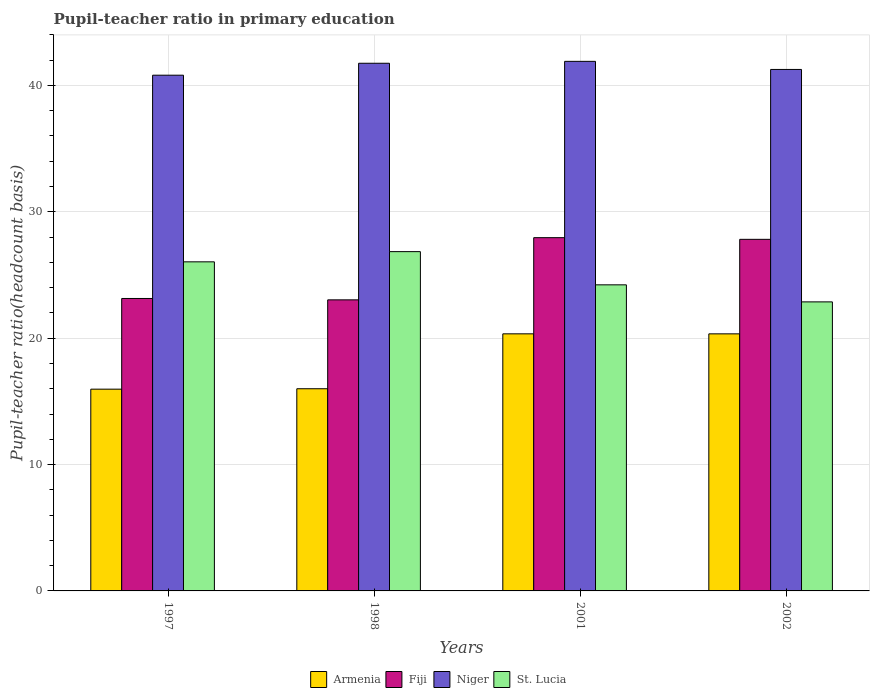How many groups of bars are there?
Ensure brevity in your answer.  4. Are the number of bars on each tick of the X-axis equal?
Make the answer very short. Yes. How many bars are there on the 3rd tick from the right?
Your response must be concise. 4. What is the label of the 1st group of bars from the left?
Your response must be concise. 1997. In how many cases, is the number of bars for a given year not equal to the number of legend labels?
Provide a succinct answer. 0. What is the pupil-teacher ratio in primary education in Niger in 2001?
Make the answer very short. 41.91. Across all years, what is the maximum pupil-teacher ratio in primary education in Fiji?
Keep it short and to the point. 27.95. Across all years, what is the minimum pupil-teacher ratio in primary education in Fiji?
Your answer should be very brief. 23.03. In which year was the pupil-teacher ratio in primary education in Armenia maximum?
Your answer should be compact. 2001. In which year was the pupil-teacher ratio in primary education in Armenia minimum?
Offer a terse response. 1997. What is the total pupil-teacher ratio in primary education in St. Lucia in the graph?
Keep it short and to the point. 99.99. What is the difference between the pupil-teacher ratio in primary education in Niger in 1997 and that in 2002?
Keep it short and to the point. -0.45. What is the difference between the pupil-teacher ratio in primary education in Niger in 1998 and the pupil-teacher ratio in primary education in St. Lucia in 2001?
Your response must be concise. 17.53. What is the average pupil-teacher ratio in primary education in Fiji per year?
Provide a short and direct response. 25.49. In the year 1997, what is the difference between the pupil-teacher ratio in primary education in St. Lucia and pupil-teacher ratio in primary education in Armenia?
Offer a terse response. 10.08. In how many years, is the pupil-teacher ratio in primary education in Niger greater than 12?
Make the answer very short. 4. What is the ratio of the pupil-teacher ratio in primary education in St. Lucia in 1997 to that in 2001?
Your answer should be very brief. 1.08. Is the pupil-teacher ratio in primary education in Armenia in 1998 less than that in 2002?
Your response must be concise. Yes. Is the difference between the pupil-teacher ratio in primary education in St. Lucia in 1997 and 2001 greater than the difference between the pupil-teacher ratio in primary education in Armenia in 1997 and 2001?
Your answer should be very brief. Yes. What is the difference between the highest and the second highest pupil-teacher ratio in primary education in St. Lucia?
Make the answer very short. 0.81. What is the difference between the highest and the lowest pupil-teacher ratio in primary education in Niger?
Provide a short and direct response. 1.1. Is it the case that in every year, the sum of the pupil-teacher ratio in primary education in Niger and pupil-teacher ratio in primary education in Armenia is greater than the sum of pupil-teacher ratio in primary education in Fiji and pupil-teacher ratio in primary education in St. Lucia?
Ensure brevity in your answer.  Yes. What does the 2nd bar from the left in 2001 represents?
Give a very brief answer. Fiji. What does the 3rd bar from the right in 2002 represents?
Provide a succinct answer. Fiji. How many years are there in the graph?
Give a very brief answer. 4. What is the difference between two consecutive major ticks on the Y-axis?
Make the answer very short. 10. Does the graph contain grids?
Give a very brief answer. Yes. Where does the legend appear in the graph?
Provide a succinct answer. Bottom center. How many legend labels are there?
Your response must be concise. 4. How are the legend labels stacked?
Your response must be concise. Horizontal. What is the title of the graph?
Provide a succinct answer. Pupil-teacher ratio in primary education. What is the label or title of the Y-axis?
Offer a terse response. Pupil-teacher ratio(headcount basis). What is the Pupil-teacher ratio(headcount basis) of Armenia in 1997?
Provide a short and direct response. 15.97. What is the Pupil-teacher ratio(headcount basis) in Fiji in 1997?
Keep it short and to the point. 23.14. What is the Pupil-teacher ratio(headcount basis) of Niger in 1997?
Offer a very short reply. 40.81. What is the Pupil-teacher ratio(headcount basis) of St. Lucia in 1997?
Keep it short and to the point. 26.04. What is the Pupil-teacher ratio(headcount basis) in Armenia in 1998?
Your answer should be very brief. 16. What is the Pupil-teacher ratio(headcount basis) of Fiji in 1998?
Your answer should be compact. 23.03. What is the Pupil-teacher ratio(headcount basis) in Niger in 1998?
Your response must be concise. 41.76. What is the Pupil-teacher ratio(headcount basis) of St. Lucia in 1998?
Give a very brief answer. 26.85. What is the Pupil-teacher ratio(headcount basis) in Armenia in 2001?
Your answer should be very brief. 20.34. What is the Pupil-teacher ratio(headcount basis) in Fiji in 2001?
Provide a short and direct response. 27.95. What is the Pupil-teacher ratio(headcount basis) of Niger in 2001?
Provide a succinct answer. 41.91. What is the Pupil-teacher ratio(headcount basis) of St. Lucia in 2001?
Provide a succinct answer. 24.22. What is the Pupil-teacher ratio(headcount basis) in Armenia in 2002?
Your response must be concise. 20.34. What is the Pupil-teacher ratio(headcount basis) of Fiji in 2002?
Make the answer very short. 27.82. What is the Pupil-teacher ratio(headcount basis) in Niger in 2002?
Give a very brief answer. 41.27. What is the Pupil-teacher ratio(headcount basis) in St. Lucia in 2002?
Provide a succinct answer. 22.87. Across all years, what is the maximum Pupil-teacher ratio(headcount basis) in Armenia?
Give a very brief answer. 20.34. Across all years, what is the maximum Pupil-teacher ratio(headcount basis) in Fiji?
Your response must be concise. 27.95. Across all years, what is the maximum Pupil-teacher ratio(headcount basis) of Niger?
Provide a succinct answer. 41.91. Across all years, what is the maximum Pupil-teacher ratio(headcount basis) of St. Lucia?
Keep it short and to the point. 26.85. Across all years, what is the minimum Pupil-teacher ratio(headcount basis) of Armenia?
Your answer should be compact. 15.97. Across all years, what is the minimum Pupil-teacher ratio(headcount basis) in Fiji?
Keep it short and to the point. 23.03. Across all years, what is the minimum Pupil-teacher ratio(headcount basis) in Niger?
Your answer should be compact. 40.81. Across all years, what is the minimum Pupil-teacher ratio(headcount basis) of St. Lucia?
Provide a succinct answer. 22.87. What is the total Pupil-teacher ratio(headcount basis) of Armenia in the graph?
Keep it short and to the point. 72.65. What is the total Pupil-teacher ratio(headcount basis) of Fiji in the graph?
Your response must be concise. 101.95. What is the total Pupil-teacher ratio(headcount basis) in Niger in the graph?
Provide a succinct answer. 165.74. What is the total Pupil-teacher ratio(headcount basis) of St. Lucia in the graph?
Your answer should be compact. 99.99. What is the difference between the Pupil-teacher ratio(headcount basis) in Armenia in 1997 and that in 1998?
Provide a succinct answer. -0.03. What is the difference between the Pupil-teacher ratio(headcount basis) of Fiji in 1997 and that in 1998?
Offer a terse response. 0.11. What is the difference between the Pupil-teacher ratio(headcount basis) of Niger in 1997 and that in 1998?
Offer a terse response. -0.94. What is the difference between the Pupil-teacher ratio(headcount basis) in St. Lucia in 1997 and that in 1998?
Your response must be concise. -0.81. What is the difference between the Pupil-teacher ratio(headcount basis) in Armenia in 1997 and that in 2001?
Keep it short and to the point. -4.38. What is the difference between the Pupil-teacher ratio(headcount basis) of Fiji in 1997 and that in 2001?
Provide a short and direct response. -4.81. What is the difference between the Pupil-teacher ratio(headcount basis) of Niger in 1997 and that in 2001?
Make the answer very short. -1.1. What is the difference between the Pupil-teacher ratio(headcount basis) of St. Lucia in 1997 and that in 2001?
Make the answer very short. 1.82. What is the difference between the Pupil-teacher ratio(headcount basis) in Armenia in 1997 and that in 2002?
Your answer should be compact. -4.38. What is the difference between the Pupil-teacher ratio(headcount basis) of Fiji in 1997 and that in 2002?
Give a very brief answer. -4.68. What is the difference between the Pupil-teacher ratio(headcount basis) in Niger in 1997 and that in 2002?
Your response must be concise. -0.46. What is the difference between the Pupil-teacher ratio(headcount basis) in St. Lucia in 1997 and that in 2002?
Offer a very short reply. 3.17. What is the difference between the Pupil-teacher ratio(headcount basis) of Armenia in 1998 and that in 2001?
Your answer should be very brief. -4.34. What is the difference between the Pupil-teacher ratio(headcount basis) of Fiji in 1998 and that in 2001?
Provide a short and direct response. -4.92. What is the difference between the Pupil-teacher ratio(headcount basis) of Niger in 1998 and that in 2001?
Offer a terse response. -0.15. What is the difference between the Pupil-teacher ratio(headcount basis) of St. Lucia in 1998 and that in 2001?
Your response must be concise. 2.63. What is the difference between the Pupil-teacher ratio(headcount basis) of Armenia in 1998 and that in 2002?
Your answer should be very brief. -4.34. What is the difference between the Pupil-teacher ratio(headcount basis) in Fiji in 1998 and that in 2002?
Give a very brief answer. -4.79. What is the difference between the Pupil-teacher ratio(headcount basis) in Niger in 1998 and that in 2002?
Make the answer very short. 0.49. What is the difference between the Pupil-teacher ratio(headcount basis) in St. Lucia in 1998 and that in 2002?
Your answer should be very brief. 3.98. What is the difference between the Pupil-teacher ratio(headcount basis) of Armenia in 2001 and that in 2002?
Offer a very short reply. 0. What is the difference between the Pupil-teacher ratio(headcount basis) of Fiji in 2001 and that in 2002?
Your response must be concise. 0.13. What is the difference between the Pupil-teacher ratio(headcount basis) in Niger in 2001 and that in 2002?
Your response must be concise. 0.64. What is the difference between the Pupil-teacher ratio(headcount basis) in St. Lucia in 2001 and that in 2002?
Your answer should be compact. 1.35. What is the difference between the Pupil-teacher ratio(headcount basis) in Armenia in 1997 and the Pupil-teacher ratio(headcount basis) in Fiji in 1998?
Make the answer very short. -7.07. What is the difference between the Pupil-teacher ratio(headcount basis) of Armenia in 1997 and the Pupil-teacher ratio(headcount basis) of Niger in 1998?
Your response must be concise. -25.79. What is the difference between the Pupil-teacher ratio(headcount basis) in Armenia in 1997 and the Pupil-teacher ratio(headcount basis) in St. Lucia in 1998?
Provide a short and direct response. -10.88. What is the difference between the Pupil-teacher ratio(headcount basis) of Fiji in 1997 and the Pupil-teacher ratio(headcount basis) of Niger in 1998?
Provide a short and direct response. -18.61. What is the difference between the Pupil-teacher ratio(headcount basis) in Fiji in 1997 and the Pupil-teacher ratio(headcount basis) in St. Lucia in 1998?
Provide a succinct answer. -3.71. What is the difference between the Pupil-teacher ratio(headcount basis) of Niger in 1997 and the Pupil-teacher ratio(headcount basis) of St. Lucia in 1998?
Your response must be concise. 13.96. What is the difference between the Pupil-teacher ratio(headcount basis) in Armenia in 1997 and the Pupil-teacher ratio(headcount basis) in Fiji in 2001?
Give a very brief answer. -11.99. What is the difference between the Pupil-teacher ratio(headcount basis) in Armenia in 1997 and the Pupil-teacher ratio(headcount basis) in Niger in 2001?
Your answer should be very brief. -25.94. What is the difference between the Pupil-teacher ratio(headcount basis) of Armenia in 1997 and the Pupil-teacher ratio(headcount basis) of St. Lucia in 2001?
Give a very brief answer. -8.26. What is the difference between the Pupil-teacher ratio(headcount basis) in Fiji in 1997 and the Pupil-teacher ratio(headcount basis) in Niger in 2001?
Your answer should be very brief. -18.76. What is the difference between the Pupil-teacher ratio(headcount basis) of Fiji in 1997 and the Pupil-teacher ratio(headcount basis) of St. Lucia in 2001?
Make the answer very short. -1.08. What is the difference between the Pupil-teacher ratio(headcount basis) of Niger in 1997 and the Pupil-teacher ratio(headcount basis) of St. Lucia in 2001?
Offer a very short reply. 16.59. What is the difference between the Pupil-teacher ratio(headcount basis) in Armenia in 1997 and the Pupil-teacher ratio(headcount basis) in Fiji in 2002?
Make the answer very short. -11.86. What is the difference between the Pupil-teacher ratio(headcount basis) in Armenia in 1997 and the Pupil-teacher ratio(headcount basis) in Niger in 2002?
Give a very brief answer. -25.3. What is the difference between the Pupil-teacher ratio(headcount basis) of Armenia in 1997 and the Pupil-teacher ratio(headcount basis) of St. Lucia in 2002?
Give a very brief answer. -6.91. What is the difference between the Pupil-teacher ratio(headcount basis) in Fiji in 1997 and the Pupil-teacher ratio(headcount basis) in Niger in 2002?
Offer a terse response. -18.12. What is the difference between the Pupil-teacher ratio(headcount basis) of Fiji in 1997 and the Pupil-teacher ratio(headcount basis) of St. Lucia in 2002?
Provide a succinct answer. 0.27. What is the difference between the Pupil-teacher ratio(headcount basis) in Niger in 1997 and the Pupil-teacher ratio(headcount basis) in St. Lucia in 2002?
Make the answer very short. 17.94. What is the difference between the Pupil-teacher ratio(headcount basis) of Armenia in 1998 and the Pupil-teacher ratio(headcount basis) of Fiji in 2001?
Offer a very short reply. -11.95. What is the difference between the Pupil-teacher ratio(headcount basis) in Armenia in 1998 and the Pupil-teacher ratio(headcount basis) in Niger in 2001?
Provide a succinct answer. -25.91. What is the difference between the Pupil-teacher ratio(headcount basis) in Armenia in 1998 and the Pupil-teacher ratio(headcount basis) in St. Lucia in 2001?
Your response must be concise. -8.22. What is the difference between the Pupil-teacher ratio(headcount basis) of Fiji in 1998 and the Pupil-teacher ratio(headcount basis) of Niger in 2001?
Your answer should be very brief. -18.87. What is the difference between the Pupil-teacher ratio(headcount basis) of Fiji in 1998 and the Pupil-teacher ratio(headcount basis) of St. Lucia in 2001?
Provide a short and direct response. -1.19. What is the difference between the Pupil-teacher ratio(headcount basis) of Niger in 1998 and the Pupil-teacher ratio(headcount basis) of St. Lucia in 2001?
Your answer should be compact. 17.53. What is the difference between the Pupil-teacher ratio(headcount basis) of Armenia in 1998 and the Pupil-teacher ratio(headcount basis) of Fiji in 2002?
Provide a succinct answer. -11.82. What is the difference between the Pupil-teacher ratio(headcount basis) of Armenia in 1998 and the Pupil-teacher ratio(headcount basis) of Niger in 2002?
Provide a short and direct response. -25.27. What is the difference between the Pupil-teacher ratio(headcount basis) of Armenia in 1998 and the Pupil-teacher ratio(headcount basis) of St. Lucia in 2002?
Provide a succinct answer. -6.87. What is the difference between the Pupil-teacher ratio(headcount basis) in Fiji in 1998 and the Pupil-teacher ratio(headcount basis) in Niger in 2002?
Your answer should be very brief. -18.23. What is the difference between the Pupil-teacher ratio(headcount basis) in Fiji in 1998 and the Pupil-teacher ratio(headcount basis) in St. Lucia in 2002?
Your response must be concise. 0.16. What is the difference between the Pupil-teacher ratio(headcount basis) of Niger in 1998 and the Pupil-teacher ratio(headcount basis) of St. Lucia in 2002?
Ensure brevity in your answer.  18.88. What is the difference between the Pupil-teacher ratio(headcount basis) of Armenia in 2001 and the Pupil-teacher ratio(headcount basis) of Fiji in 2002?
Your answer should be compact. -7.48. What is the difference between the Pupil-teacher ratio(headcount basis) in Armenia in 2001 and the Pupil-teacher ratio(headcount basis) in Niger in 2002?
Keep it short and to the point. -20.92. What is the difference between the Pupil-teacher ratio(headcount basis) in Armenia in 2001 and the Pupil-teacher ratio(headcount basis) in St. Lucia in 2002?
Provide a short and direct response. -2.53. What is the difference between the Pupil-teacher ratio(headcount basis) in Fiji in 2001 and the Pupil-teacher ratio(headcount basis) in Niger in 2002?
Your answer should be very brief. -13.31. What is the difference between the Pupil-teacher ratio(headcount basis) of Fiji in 2001 and the Pupil-teacher ratio(headcount basis) of St. Lucia in 2002?
Keep it short and to the point. 5.08. What is the difference between the Pupil-teacher ratio(headcount basis) in Niger in 2001 and the Pupil-teacher ratio(headcount basis) in St. Lucia in 2002?
Offer a terse response. 19.03. What is the average Pupil-teacher ratio(headcount basis) in Armenia per year?
Provide a short and direct response. 18.16. What is the average Pupil-teacher ratio(headcount basis) in Fiji per year?
Your answer should be very brief. 25.49. What is the average Pupil-teacher ratio(headcount basis) of Niger per year?
Make the answer very short. 41.43. What is the average Pupil-teacher ratio(headcount basis) of St. Lucia per year?
Your answer should be compact. 25. In the year 1997, what is the difference between the Pupil-teacher ratio(headcount basis) in Armenia and Pupil-teacher ratio(headcount basis) in Fiji?
Offer a very short reply. -7.18. In the year 1997, what is the difference between the Pupil-teacher ratio(headcount basis) of Armenia and Pupil-teacher ratio(headcount basis) of Niger?
Provide a short and direct response. -24.84. In the year 1997, what is the difference between the Pupil-teacher ratio(headcount basis) in Armenia and Pupil-teacher ratio(headcount basis) in St. Lucia?
Your answer should be compact. -10.08. In the year 1997, what is the difference between the Pupil-teacher ratio(headcount basis) of Fiji and Pupil-teacher ratio(headcount basis) of Niger?
Make the answer very short. -17.67. In the year 1997, what is the difference between the Pupil-teacher ratio(headcount basis) of Fiji and Pupil-teacher ratio(headcount basis) of St. Lucia?
Your answer should be compact. -2.9. In the year 1997, what is the difference between the Pupil-teacher ratio(headcount basis) of Niger and Pupil-teacher ratio(headcount basis) of St. Lucia?
Keep it short and to the point. 14.77. In the year 1998, what is the difference between the Pupil-teacher ratio(headcount basis) in Armenia and Pupil-teacher ratio(headcount basis) in Fiji?
Your response must be concise. -7.03. In the year 1998, what is the difference between the Pupil-teacher ratio(headcount basis) in Armenia and Pupil-teacher ratio(headcount basis) in Niger?
Your response must be concise. -25.76. In the year 1998, what is the difference between the Pupil-teacher ratio(headcount basis) of Armenia and Pupil-teacher ratio(headcount basis) of St. Lucia?
Provide a short and direct response. -10.85. In the year 1998, what is the difference between the Pupil-teacher ratio(headcount basis) of Fiji and Pupil-teacher ratio(headcount basis) of Niger?
Ensure brevity in your answer.  -18.72. In the year 1998, what is the difference between the Pupil-teacher ratio(headcount basis) in Fiji and Pupil-teacher ratio(headcount basis) in St. Lucia?
Keep it short and to the point. -3.82. In the year 1998, what is the difference between the Pupil-teacher ratio(headcount basis) of Niger and Pupil-teacher ratio(headcount basis) of St. Lucia?
Offer a very short reply. 14.91. In the year 2001, what is the difference between the Pupil-teacher ratio(headcount basis) of Armenia and Pupil-teacher ratio(headcount basis) of Fiji?
Provide a short and direct response. -7.61. In the year 2001, what is the difference between the Pupil-teacher ratio(headcount basis) of Armenia and Pupil-teacher ratio(headcount basis) of Niger?
Provide a succinct answer. -21.56. In the year 2001, what is the difference between the Pupil-teacher ratio(headcount basis) in Armenia and Pupil-teacher ratio(headcount basis) in St. Lucia?
Make the answer very short. -3.88. In the year 2001, what is the difference between the Pupil-teacher ratio(headcount basis) in Fiji and Pupil-teacher ratio(headcount basis) in Niger?
Your response must be concise. -13.95. In the year 2001, what is the difference between the Pupil-teacher ratio(headcount basis) of Fiji and Pupil-teacher ratio(headcount basis) of St. Lucia?
Keep it short and to the point. 3.73. In the year 2001, what is the difference between the Pupil-teacher ratio(headcount basis) in Niger and Pupil-teacher ratio(headcount basis) in St. Lucia?
Offer a very short reply. 17.68. In the year 2002, what is the difference between the Pupil-teacher ratio(headcount basis) of Armenia and Pupil-teacher ratio(headcount basis) of Fiji?
Give a very brief answer. -7.48. In the year 2002, what is the difference between the Pupil-teacher ratio(headcount basis) of Armenia and Pupil-teacher ratio(headcount basis) of Niger?
Make the answer very short. -20.92. In the year 2002, what is the difference between the Pupil-teacher ratio(headcount basis) of Armenia and Pupil-teacher ratio(headcount basis) of St. Lucia?
Make the answer very short. -2.53. In the year 2002, what is the difference between the Pupil-teacher ratio(headcount basis) of Fiji and Pupil-teacher ratio(headcount basis) of Niger?
Keep it short and to the point. -13.44. In the year 2002, what is the difference between the Pupil-teacher ratio(headcount basis) of Fiji and Pupil-teacher ratio(headcount basis) of St. Lucia?
Your response must be concise. 4.95. In the year 2002, what is the difference between the Pupil-teacher ratio(headcount basis) in Niger and Pupil-teacher ratio(headcount basis) in St. Lucia?
Offer a terse response. 18.39. What is the ratio of the Pupil-teacher ratio(headcount basis) in Fiji in 1997 to that in 1998?
Provide a succinct answer. 1. What is the ratio of the Pupil-teacher ratio(headcount basis) of Niger in 1997 to that in 1998?
Offer a very short reply. 0.98. What is the ratio of the Pupil-teacher ratio(headcount basis) of St. Lucia in 1997 to that in 1998?
Offer a terse response. 0.97. What is the ratio of the Pupil-teacher ratio(headcount basis) in Armenia in 1997 to that in 2001?
Offer a terse response. 0.78. What is the ratio of the Pupil-teacher ratio(headcount basis) of Fiji in 1997 to that in 2001?
Offer a terse response. 0.83. What is the ratio of the Pupil-teacher ratio(headcount basis) in Niger in 1997 to that in 2001?
Make the answer very short. 0.97. What is the ratio of the Pupil-teacher ratio(headcount basis) in St. Lucia in 1997 to that in 2001?
Your response must be concise. 1.08. What is the ratio of the Pupil-teacher ratio(headcount basis) in Armenia in 1997 to that in 2002?
Provide a succinct answer. 0.78. What is the ratio of the Pupil-teacher ratio(headcount basis) in Fiji in 1997 to that in 2002?
Ensure brevity in your answer.  0.83. What is the ratio of the Pupil-teacher ratio(headcount basis) in St. Lucia in 1997 to that in 2002?
Provide a short and direct response. 1.14. What is the ratio of the Pupil-teacher ratio(headcount basis) of Armenia in 1998 to that in 2001?
Keep it short and to the point. 0.79. What is the ratio of the Pupil-teacher ratio(headcount basis) in Fiji in 1998 to that in 2001?
Keep it short and to the point. 0.82. What is the ratio of the Pupil-teacher ratio(headcount basis) in St. Lucia in 1998 to that in 2001?
Give a very brief answer. 1.11. What is the ratio of the Pupil-teacher ratio(headcount basis) of Armenia in 1998 to that in 2002?
Your answer should be very brief. 0.79. What is the ratio of the Pupil-teacher ratio(headcount basis) in Fiji in 1998 to that in 2002?
Give a very brief answer. 0.83. What is the ratio of the Pupil-teacher ratio(headcount basis) in Niger in 1998 to that in 2002?
Offer a very short reply. 1.01. What is the ratio of the Pupil-teacher ratio(headcount basis) in St. Lucia in 1998 to that in 2002?
Your answer should be very brief. 1.17. What is the ratio of the Pupil-teacher ratio(headcount basis) in Niger in 2001 to that in 2002?
Offer a very short reply. 1.02. What is the ratio of the Pupil-teacher ratio(headcount basis) of St. Lucia in 2001 to that in 2002?
Give a very brief answer. 1.06. What is the difference between the highest and the second highest Pupil-teacher ratio(headcount basis) in Armenia?
Your answer should be compact. 0. What is the difference between the highest and the second highest Pupil-teacher ratio(headcount basis) of Fiji?
Your answer should be very brief. 0.13. What is the difference between the highest and the second highest Pupil-teacher ratio(headcount basis) in Niger?
Provide a short and direct response. 0.15. What is the difference between the highest and the second highest Pupil-teacher ratio(headcount basis) in St. Lucia?
Provide a succinct answer. 0.81. What is the difference between the highest and the lowest Pupil-teacher ratio(headcount basis) in Armenia?
Make the answer very short. 4.38. What is the difference between the highest and the lowest Pupil-teacher ratio(headcount basis) of Fiji?
Your answer should be very brief. 4.92. What is the difference between the highest and the lowest Pupil-teacher ratio(headcount basis) of Niger?
Your response must be concise. 1.1. What is the difference between the highest and the lowest Pupil-teacher ratio(headcount basis) in St. Lucia?
Offer a very short reply. 3.98. 